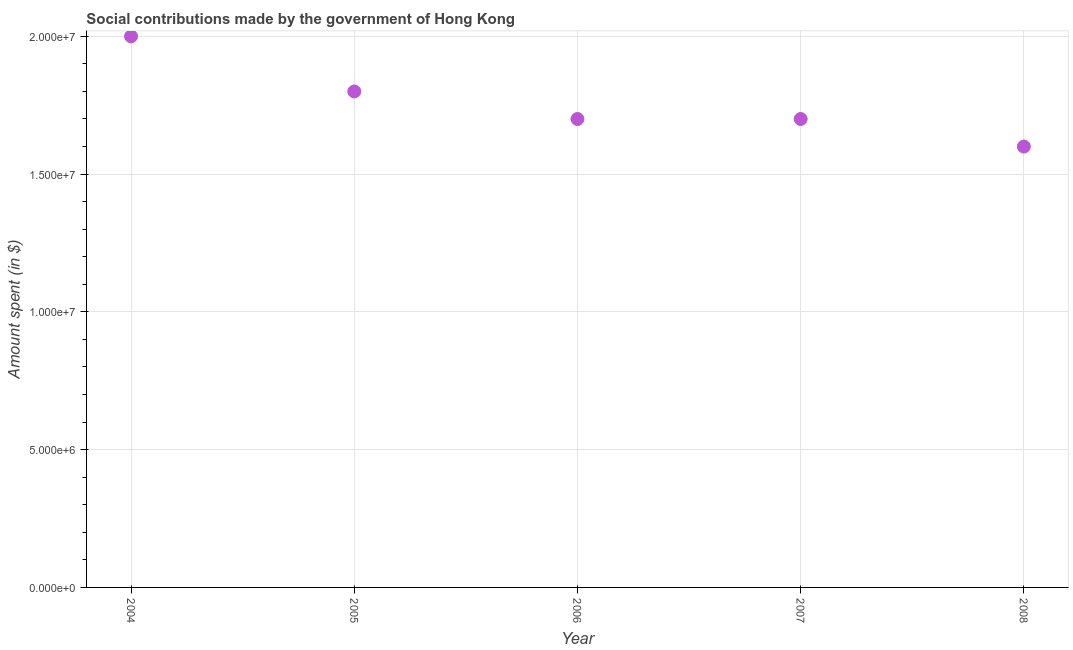What is the amount spent in making social contributions in 2006?
Give a very brief answer. 1.70e+07. Across all years, what is the maximum amount spent in making social contributions?
Your answer should be compact. 2.00e+07. Across all years, what is the minimum amount spent in making social contributions?
Give a very brief answer. 1.60e+07. In which year was the amount spent in making social contributions maximum?
Make the answer very short. 2004. In which year was the amount spent in making social contributions minimum?
Keep it short and to the point. 2008. What is the sum of the amount spent in making social contributions?
Your response must be concise. 8.80e+07. What is the difference between the amount spent in making social contributions in 2006 and 2007?
Offer a terse response. 0. What is the average amount spent in making social contributions per year?
Your answer should be compact. 1.76e+07. What is the median amount spent in making social contributions?
Offer a terse response. 1.70e+07. What is the ratio of the amount spent in making social contributions in 2005 to that in 2006?
Your response must be concise. 1.06. Is the sum of the amount spent in making social contributions in 2004 and 2005 greater than the maximum amount spent in making social contributions across all years?
Keep it short and to the point. Yes. What is the difference between the highest and the lowest amount spent in making social contributions?
Your response must be concise. 4.00e+06. In how many years, is the amount spent in making social contributions greater than the average amount spent in making social contributions taken over all years?
Make the answer very short. 2. Are the values on the major ticks of Y-axis written in scientific E-notation?
Keep it short and to the point. Yes. Does the graph contain any zero values?
Your answer should be compact. No. Does the graph contain grids?
Ensure brevity in your answer.  Yes. What is the title of the graph?
Your answer should be very brief. Social contributions made by the government of Hong Kong. What is the label or title of the Y-axis?
Offer a terse response. Amount spent (in $). What is the Amount spent (in $) in 2004?
Your answer should be very brief. 2.00e+07. What is the Amount spent (in $) in 2005?
Your answer should be very brief. 1.80e+07. What is the Amount spent (in $) in 2006?
Make the answer very short. 1.70e+07. What is the Amount spent (in $) in 2007?
Make the answer very short. 1.70e+07. What is the Amount spent (in $) in 2008?
Make the answer very short. 1.60e+07. What is the difference between the Amount spent (in $) in 2004 and 2005?
Your answer should be compact. 2.00e+06. What is the difference between the Amount spent (in $) in 2004 and 2006?
Make the answer very short. 3.00e+06. What is the difference between the Amount spent (in $) in 2004 and 2008?
Your response must be concise. 4.00e+06. What is the difference between the Amount spent (in $) in 2005 and 2006?
Provide a succinct answer. 1.00e+06. What is the difference between the Amount spent (in $) in 2006 and 2007?
Provide a succinct answer. 0. What is the difference between the Amount spent (in $) in 2006 and 2008?
Ensure brevity in your answer.  1.00e+06. What is the difference between the Amount spent (in $) in 2007 and 2008?
Your answer should be very brief. 1.00e+06. What is the ratio of the Amount spent (in $) in 2004 to that in 2005?
Ensure brevity in your answer.  1.11. What is the ratio of the Amount spent (in $) in 2004 to that in 2006?
Your answer should be very brief. 1.18. What is the ratio of the Amount spent (in $) in 2004 to that in 2007?
Make the answer very short. 1.18. What is the ratio of the Amount spent (in $) in 2004 to that in 2008?
Provide a succinct answer. 1.25. What is the ratio of the Amount spent (in $) in 2005 to that in 2006?
Offer a very short reply. 1.06. What is the ratio of the Amount spent (in $) in 2005 to that in 2007?
Provide a short and direct response. 1.06. What is the ratio of the Amount spent (in $) in 2005 to that in 2008?
Offer a terse response. 1.12. What is the ratio of the Amount spent (in $) in 2006 to that in 2008?
Offer a terse response. 1.06. What is the ratio of the Amount spent (in $) in 2007 to that in 2008?
Give a very brief answer. 1.06. 